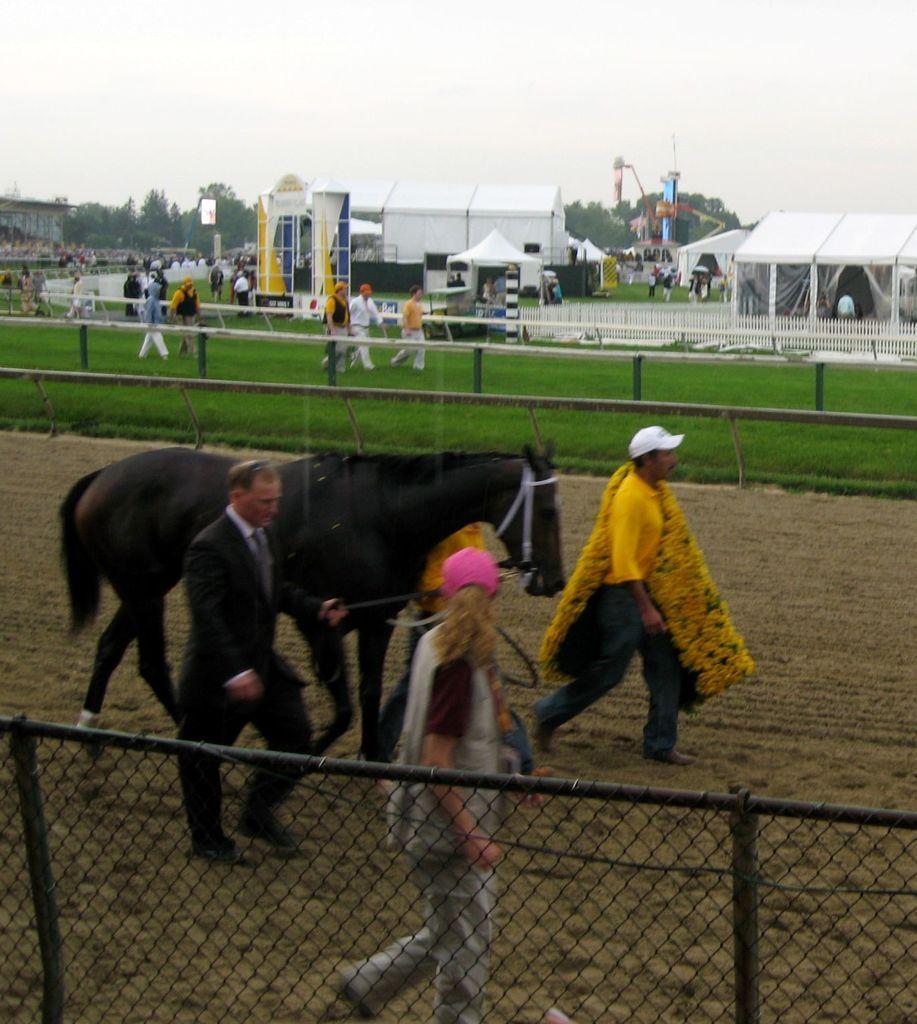Could you give a brief overview of what you see in this image? In this image we can see horse and three people walking on the ground, here we can see the fence, a few more people walking on the grass, we can see tents, trees and sky in the background. 